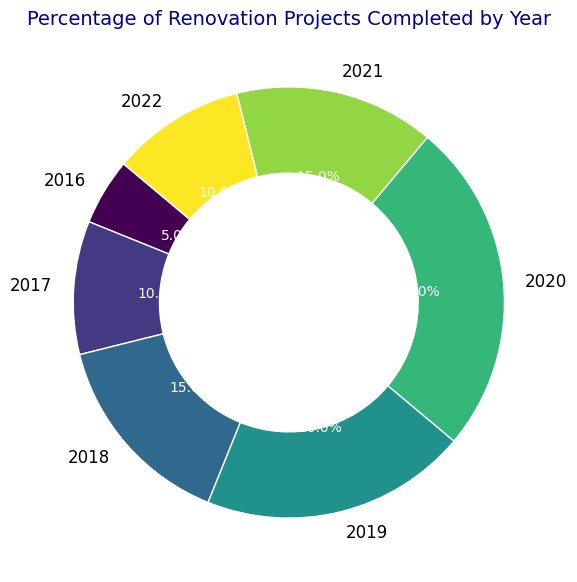What's the total percentage of renovation projects completed from 2016 to 2019? To find the total percentage, sum the individual percentages of each year from 2016 to 2019. That is: 5% (2016) + 10% (2017) + 15% (2018) + 20% (2019) = 50%
Answer: 50% In which year was the highest percentage of renovation projects completed? Look at the labels and percentages on the ring chart. The highest percentage is in 2020 at 25%.
Answer: 2020 Which two years have the same percentage of renovation projects completed? Comparing the percentage values, you can see that 2017 and 2022 both have 10%, and 2018 and 2021 both have 15%.
Answer: 2017 and 2022; 2018 and 2021 Is the percentage of renovation projects completed in 2020 greater than the combined percentages of 2016 and 2017? First calculate the combined percentage of 2016 and 2017: 5% + 10% = 15%. The percentage in 2020 is 25%, which is greater than 15%.
Answer: Yes What's the difference in the percentage of renovation projects completed between 2020 and 2021? Subtract the percentage of 2021 from that of 2020: 25% (2020) - 15% (2021) = 10%.
Answer: 10% How much greater is the percentage of renovation projects completed in 2019 compared to 2016? Subtract the percentage of 2016 from that of 2019: 20% (2019) - 5% (2016) = 15%.
Answer: 15% Which year marked the start of a decline in the percentage of completed renovation projects after a consistent rise? Observe the sequence of the percentages: there is a consistent rise from 2016 to 2020, after which there is a decline in 2021. Thus, the decline starts after 2020.
Answer: 2021 What is the average percentage of renovation projects completed from 2016 to 2022? Add the percentages from each year, then divide by the total number of years: (5% + 10% + 15% + 20% + 25% + 15% + 10%) / 7 ≈ 14.29%.
Answer: ~14.29% Identify the color used for the segment representing 2021 projects. Visual observation of the ring chart reveals that the segment labeled 2021 is using a light shade of color from the gradient applied (corresponding to a middle value).
Answer: Light shade of color from the gradient 